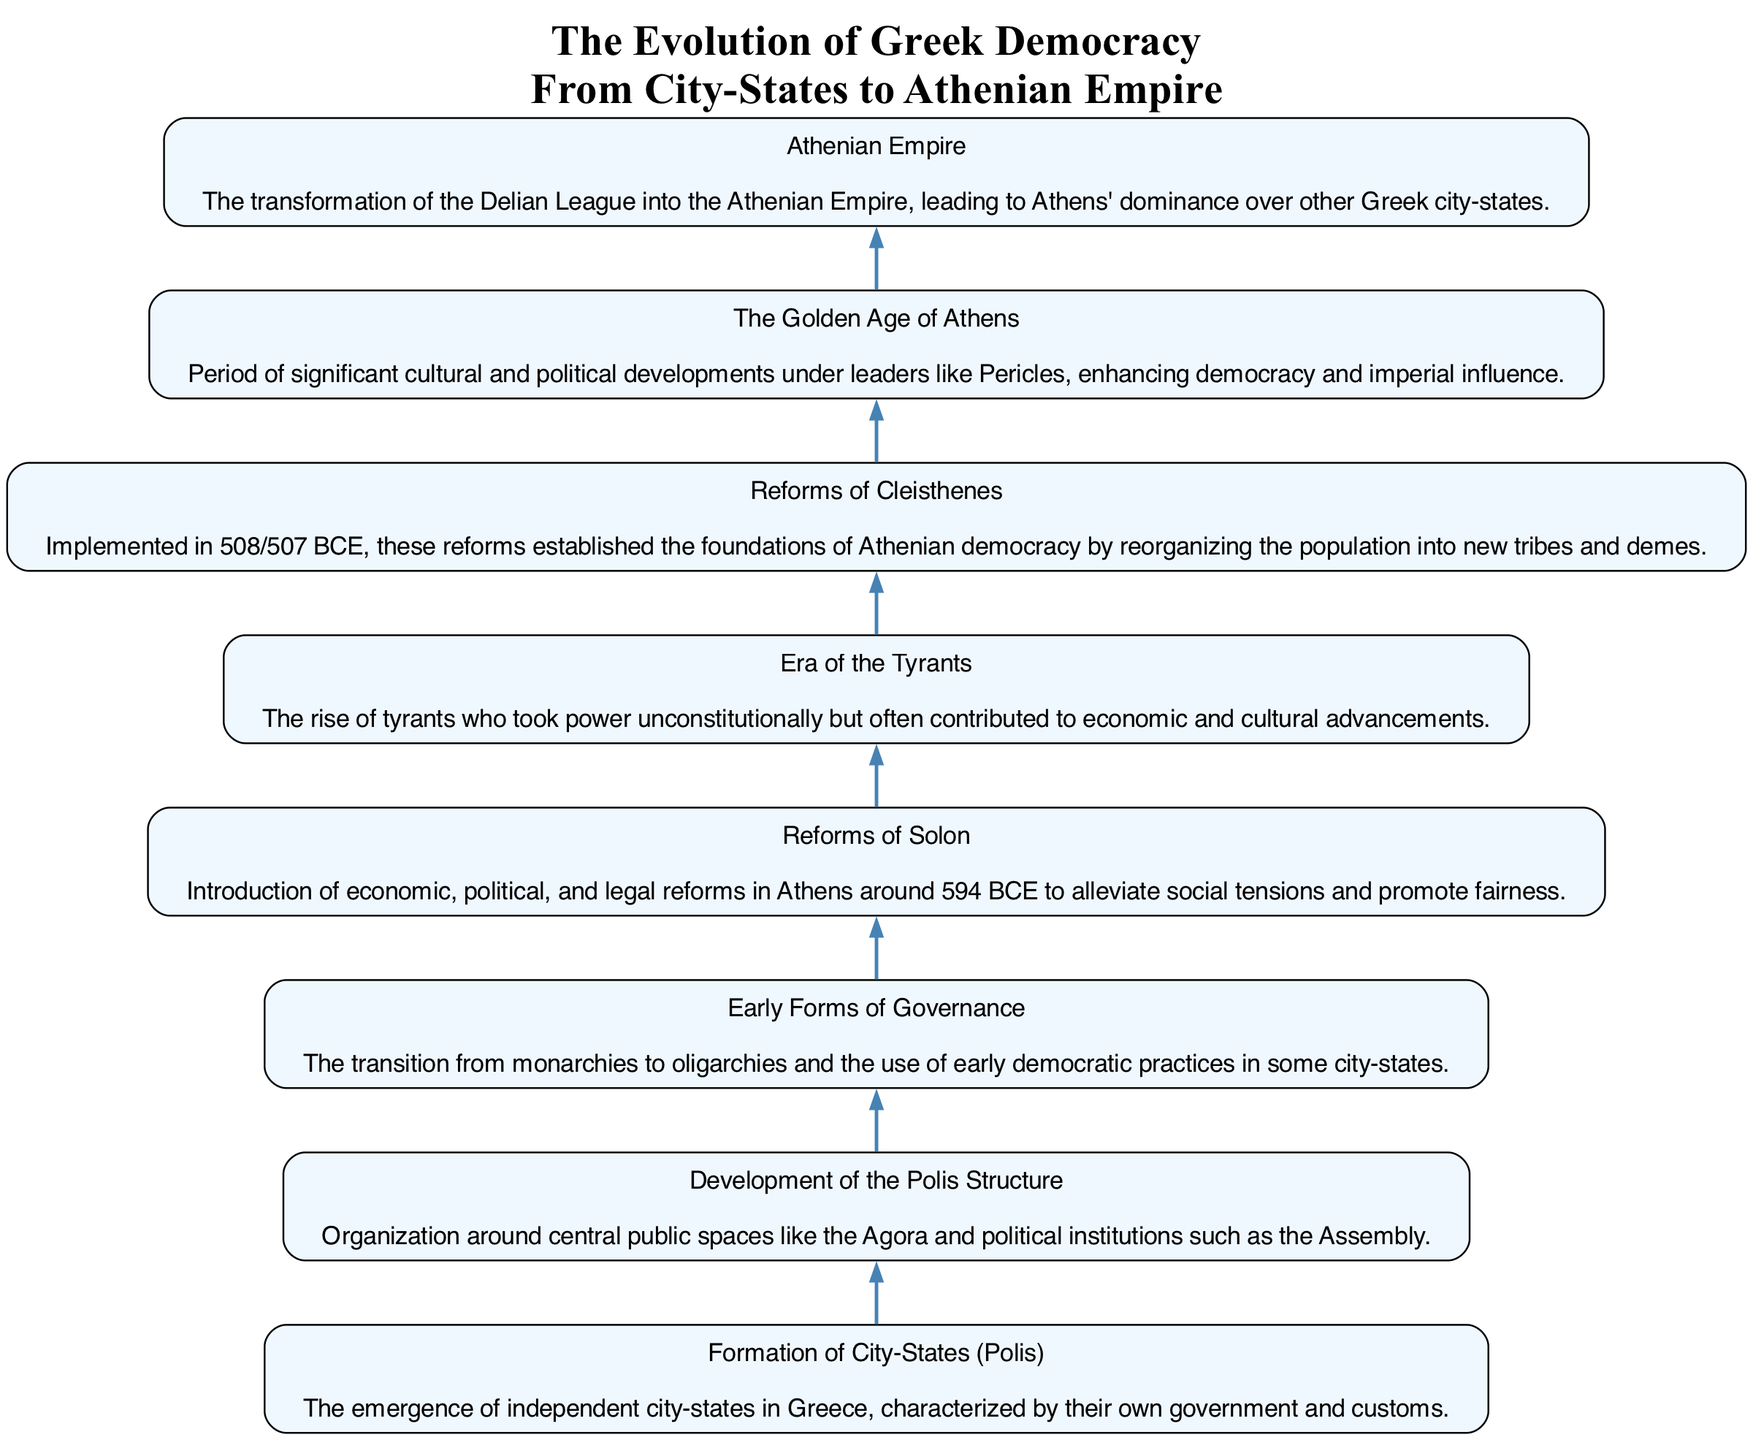What is the first step in the evolution of Greek democracy? The first step listed in the diagram is "Formation of City-States (Polis)", which indicates the beginning of the evolution.
Answer: Formation of City-States (Polis) How many steps are there in the diagram? By counting the nodes in the diagram, there are a total of eight steps that outline the evolution of Greek democracy.
Answer: Eight Which step precedes the "Reforms of Cleisthenes"? The diagram shows that the step "Era of the Tyrants" is positioned immediately before the "Reforms of Cleisthenes", indicating its sequential occurrence.
Answer: Era of the Tyrants What major transformation is illustrated after "The Golden Age of Athens"? The diagram transitions from "The Golden Age of Athens" to "Athenian Empire", depicting the change in political influence and structure.
Answer: Athenian Empire What was the purpose of the "Reforms of Solon"? The description indicates that the "Reforms of Solon" were aimed at alleviating social tensions and promoting fairness, reflecting the social and political needs of the time.
Answer: Alleviating social tensions and promoting fairness Which two steps involve reformations in governance? The steps "Reforms of Solon" and "Reforms of Cleisthenes" both focus on introducing significant changes in governance structure and practices within Athens.
Answer: Reforms of Solon and Reforms of Cleisthenes What does the "Athenian Empire" signify in the timeline? The "Athenian Empire" signifies the culmination of earlier developments, particularly the transformation of the Delian League into a dominant political entity in Greece.
Answer: Transformation of the Delian League Which step is directly followed by "The Golden Age of Athens"? According to the diagram, "Reforms of Cleisthenes" directly leads to "The Golden Age of Athens", showcasing the impact of reforms on Athenian society.
Answer: Reforms of Cleisthenes 